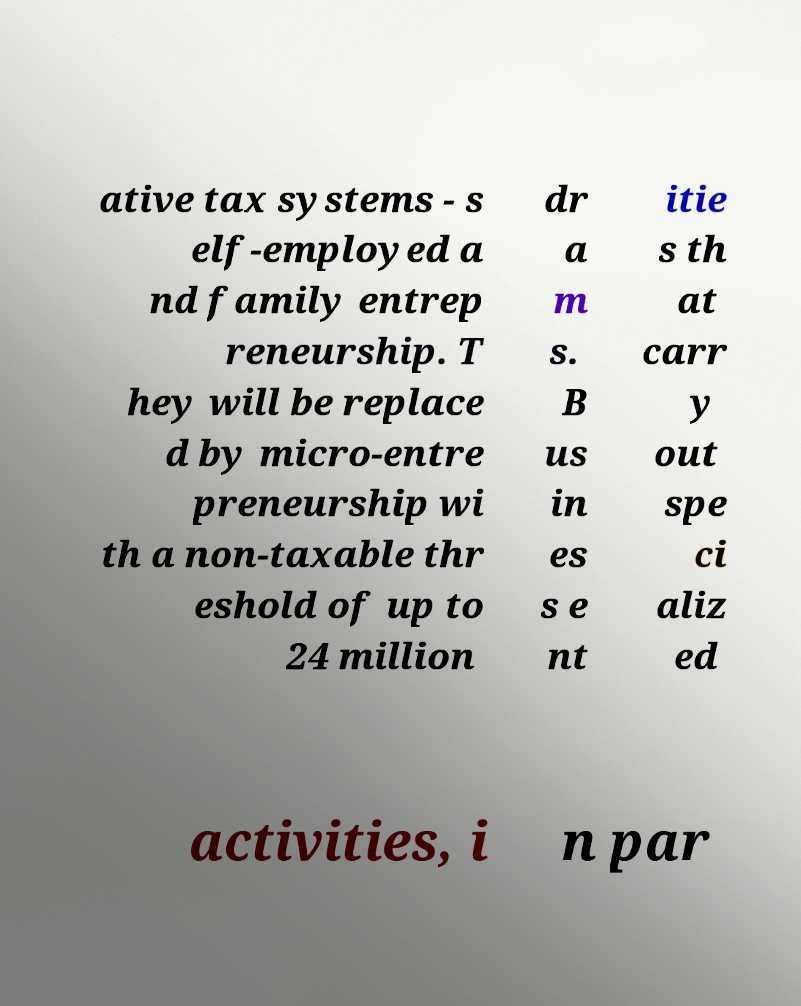There's text embedded in this image that I need extracted. Can you transcribe it verbatim? ative tax systems - s elf-employed a nd family entrep reneurship. T hey will be replace d by micro-entre preneurship wi th a non-taxable thr eshold of up to 24 million dr a m s. B us in es s e nt itie s th at carr y out spe ci aliz ed activities, i n par 